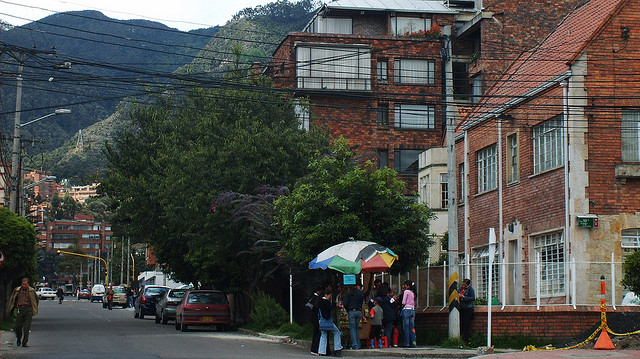Can you describe the types of transportation visible in the picture? There are several cars parked along the side of the street, and the setup suggests that it's a typical urban road used for vehicular traffic. No buses or bicycles are visible. Are there any notable architectural features in the buildings shown? The architecture includes multi-storied buildings with a mix of brick and what appears to be stucco exteriors, balconies, and large windows, typical of residential city structures. 